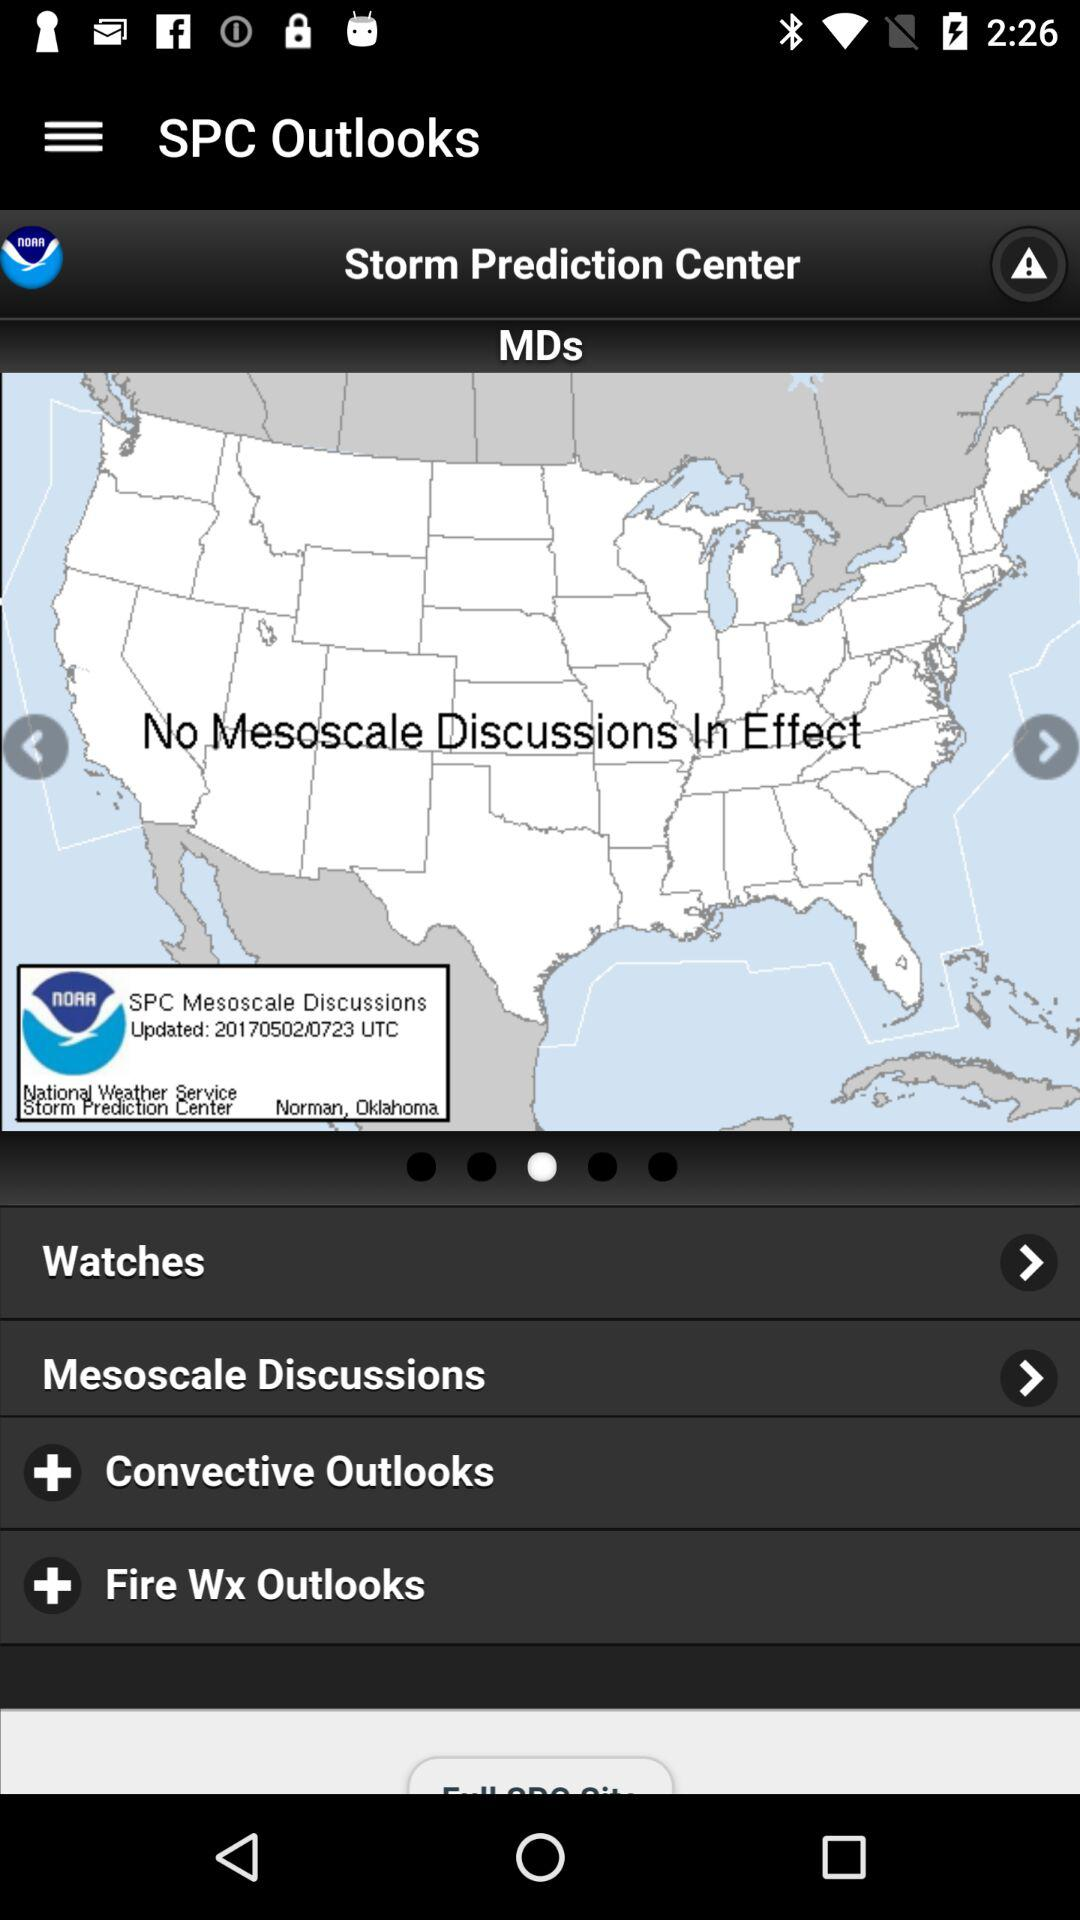What is the app name? The app name is "SPC Outlooks". 